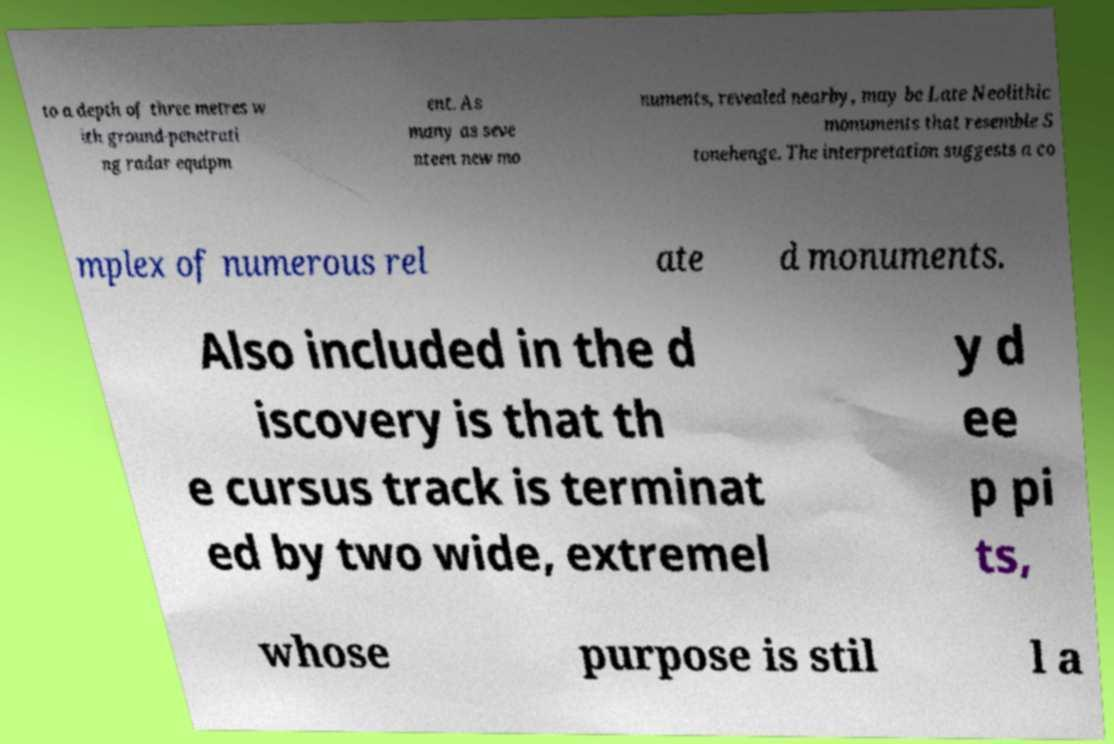Could you extract and type out the text from this image? to a depth of three metres w ith ground-penetrati ng radar equipm ent. As many as seve nteen new mo numents, revealed nearby, may be Late Neolithic monuments that resemble S tonehenge. The interpretation suggests a co mplex of numerous rel ate d monuments. Also included in the d iscovery is that th e cursus track is terminat ed by two wide, extremel y d ee p pi ts, whose purpose is stil l a 